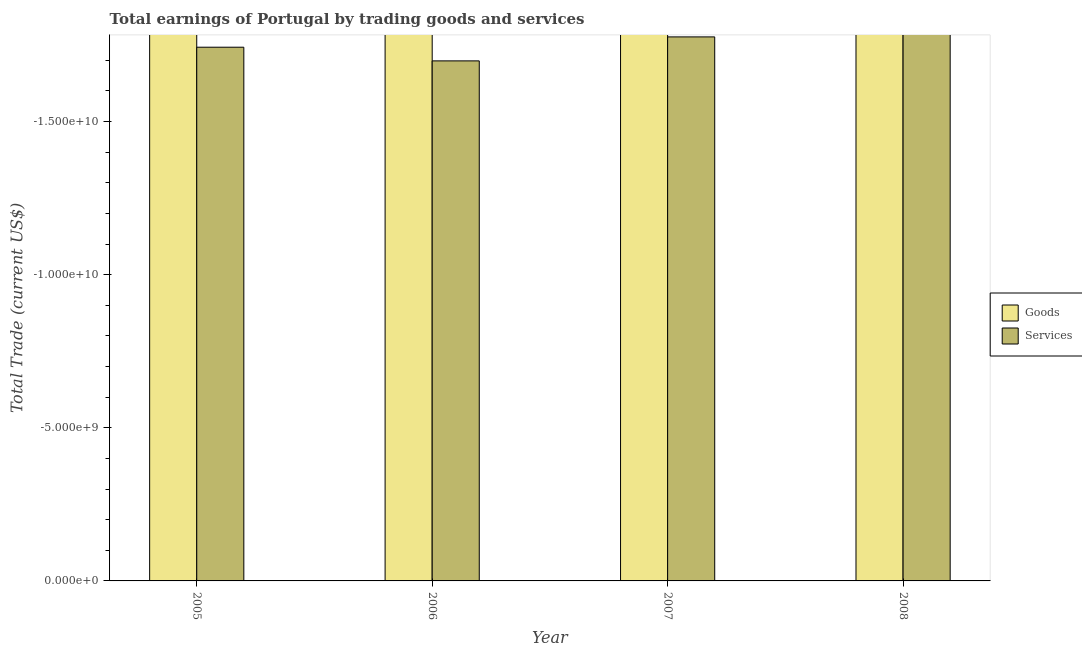How many different coloured bars are there?
Offer a very short reply. 0. Are the number of bars per tick equal to the number of legend labels?
Offer a very short reply. No. Are the number of bars on each tick of the X-axis equal?
Provide a succinct answer. Yes. What is the label of the 3rd group of bars from the left?
Give a very brief answer. 2007. What is the amount earned by trading services in 2005?
Make the answer very short. 0. What is the average amount earned by trading services per year?
Your response must be concise. 0. In how many years, is the amount earned by trading services greater than -10000000000 US$?
Provide a succinct answer. 0. How many years are there in the graph?
Your answer should be compact. 4. What is the difference between two consecutive major ticks on the Y-axis?
Offer a very short reply. 5.00e+09. Does the graph contain any zero values?
Ensure brevity in your answer.  Yes. Does the graph contain grids?
Provide a short and direct response. No. Where does the legend appear in the graph?
Offer a very short reply. Center right. How are the legend labels stacked?
Offer a very short reply. Vertical. What is the title of the graph?
Make the answer very short. Total earnings of Portugal by trading goods and services. What is the label or title of the X-axis?
Make the answer very short. Year. What is the label or title of the Y-axis?
Offer a very short reply. Total Trade (current US$). What is the Total Trade (current US$) of Goods in 2006?
Your answer should be compact. 0. What is the Total Trade (current US$) of Services in 2006?
Make the answer very short. 0. What is the total Total Trade (current US$) of Services in the graph?
Provide a succinct answer. 0. What is the average Total Trade (current US$) of Goods per year?
Your response must be concise. 0. 